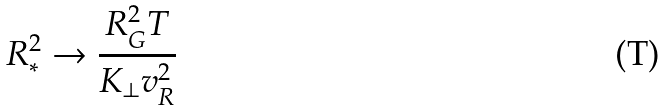Convert formula to latex. <formula><loc_0><loc_0><loc_500><loc_500>R _ { * } ^ { 2 } \rightarrow \frac { R _ { G } ^ { 2 } T } { K _ { \perp } v _ { R } ^ { 2 } }</formula> 